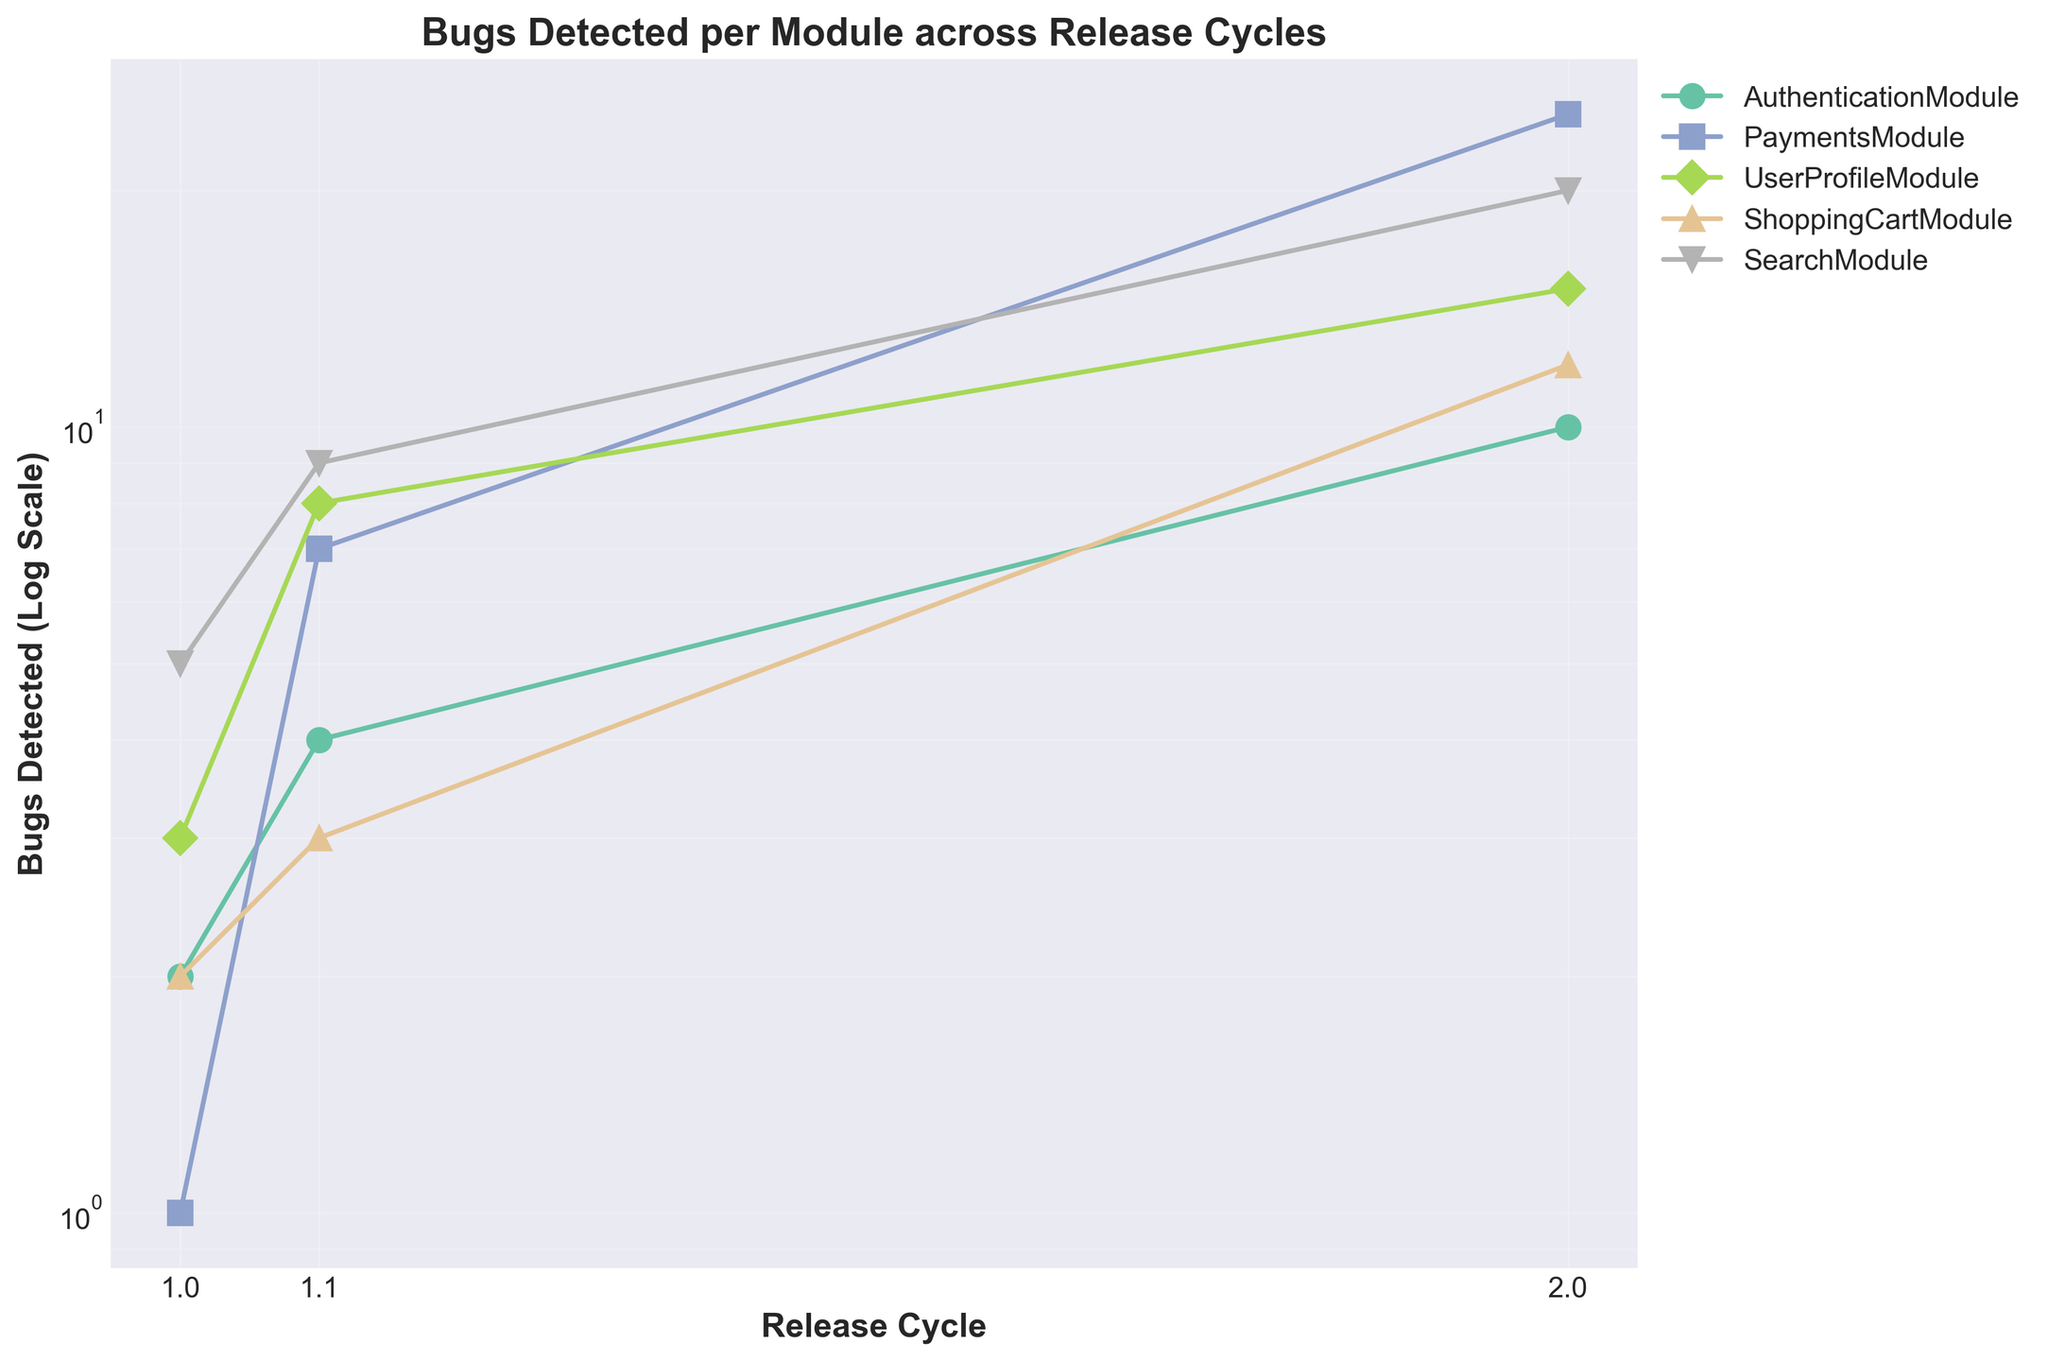what is the title of the plot? The title of the plot is provided at the top center of the figure. It gives an overall description of what the plot represents.
Answer: Bugs Detected per Module across Release Cycles how many release cycles are displayed on the x-axis? The x-axis has release cycle labels, and counting these labels will tell us how many release cycles are displayed.
Answer: 3 which module detected the highest number of bugs in release cycle 1.0? By looking at the y-values for each module at release cycle 1.0, we can identify the module with the highest number of bugs.
Answer: SearchModule what is the range of bugs detected in the PaymentsModule across all release cycles? Check the y-values for the PaymentsModule across release cycles 1.0, 1.1, and 2.0 to determine the range from the minimum to the maximum number of bugs.
Answer: 1 to 25 how does the number of bugs in the UserProfileModule change from release cycle 1.1 to 2.0? Compare the y-values corresponding to UserProfileModule at release cycles 1.1 and 2.0 to determine the change in the number of bugs.
Answer: increased by 7 which module shows the least increase in bugs from release cycle 1.0 to 2.0? Calculate the difference in the number of bugs for each module between release cycles 1.0 to 2.0, and identify the smallest increase.
Answer: AuthenticationModule what is the average number of bugs detected in release cycle 1.1 across all modules? Sum the number of bugs for all modules in release cycle 1.1, then divide by the number of modules to find the average.
Answer: (4 + 7 + 8 + 3 + 9) / 5 = 6.2 which module has a more dramatic increase in bugs detected between release cycle 1.1 and 2.0: ShoppingCartModule or SearchModule? Compare the difference in the number of bugs detected for ShoppingCartModule and SearchModule between release cycles 1.1 and 2.0.
Answer: SearchModule how many data points are plotted for each module? For each module, count the number of data points plotted at each release cycle to extend this to all modules.
Answer: 3 